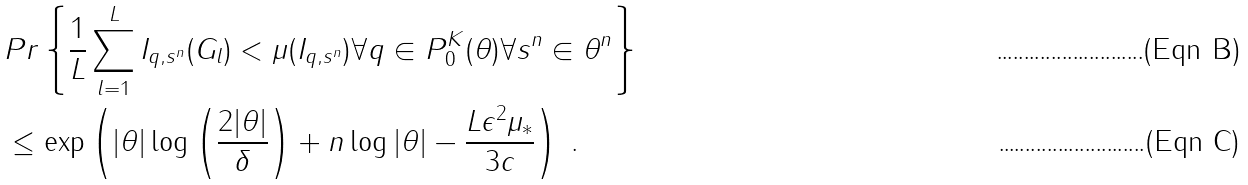<formula> <loc_0><loc_0><loc_500><loc_500>& P r \left \{ \frac { 1 } { L } \sum _ { l = 1 } ^ { L } I _ { q , s ^ { n } } ( G _ { l } ) < \mu ( I _ { q , s ^ { n } } ) \forall q \in P _ { 0 } ^ { K } ( \theta ) \forall s ^ { n } \in \theta ^ { n } \right \} \\ & \leq \exp \left ( | \theta | \log \left ( \frac { 2 | \theta | } { \delta } \right ) + n \log | \theta | - \frac { L \epsilon ^ { 2 } \mu _ { * } } { 3 c } \right ) \text { .}</formula> 